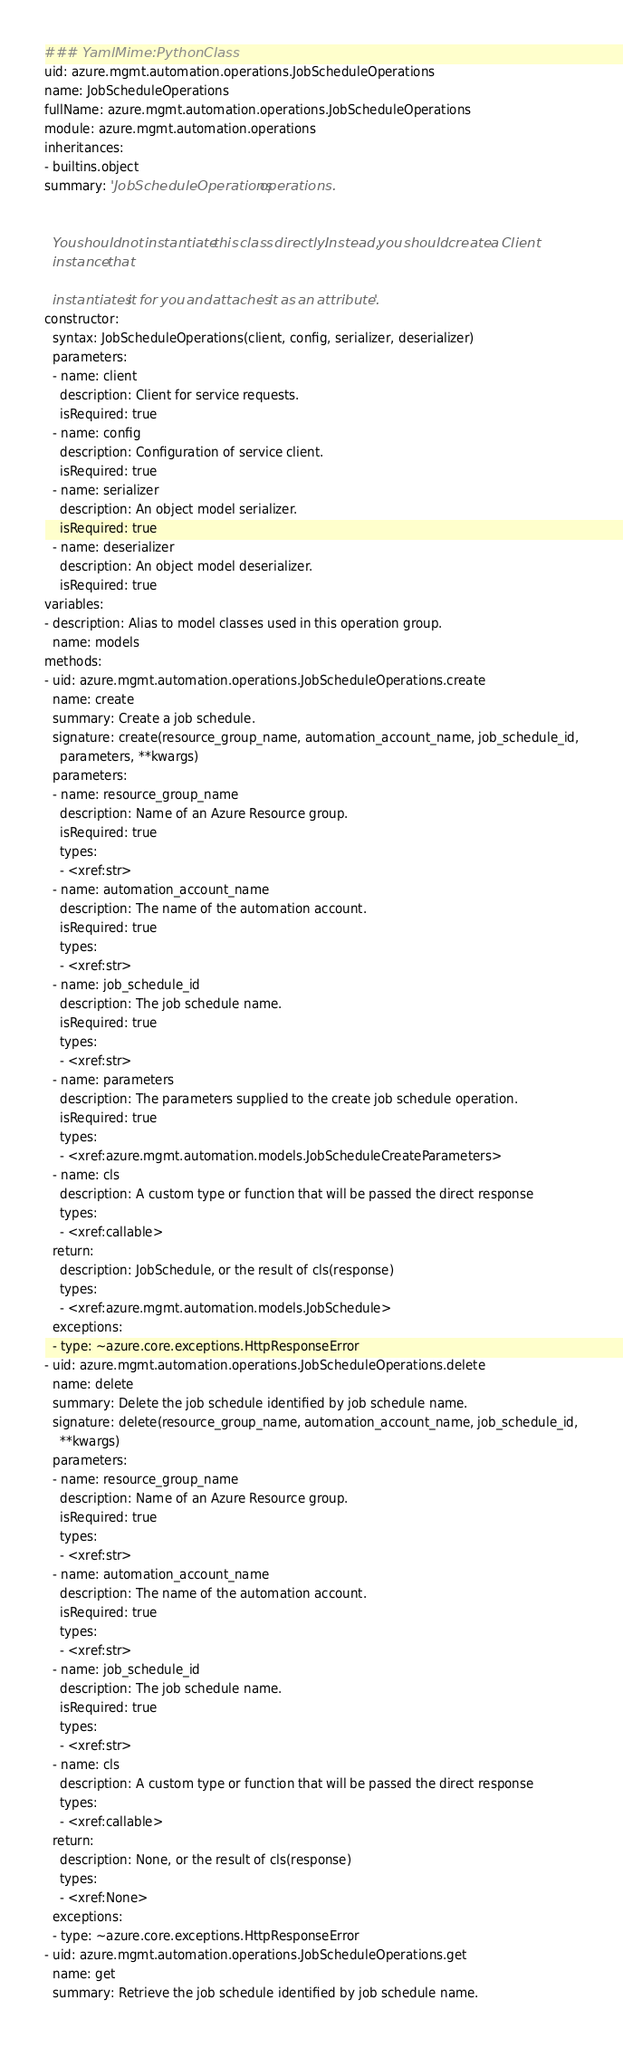Convert code to text. <code><loc_0><loc_0><loc_500><loc_500><_YAML_>### YamlMime:PythonClass
uid: azure.mgmt.automation.operations.JobScheduleOperations
name: JobScheduleOperations
fullName: azure.mgmt.automation.operations.JobScheduleOperations
module: azure.mgmt.automation.operations
inheritances:
- builtins.object
summary: 'JobScheduleOperations operations.


  You should not instantiate this class directly. Instead, you should create a Client
  instance that

  instantiates it for you and attaches it as an attribute.'
constructor:
  syntax: JobScheduleOperations(client, config, serializer, deserializer)
  parameters:
  - name: client
    description: Client for service requests.
    isRequired: true
  - name: config
    description: Configuration of service client.
    isRequired: true
  - name: serializer
    description: An object model serializer.
    isRequired: true
  - name: deserializer
    description: An object model deserializer.
    isRequired: true
variables:
- description: Alias to model classes used in this operation group.
  name: models
methods:
- uid: azure.mgmt.automation.operations.JobScheduleOperations.create
  name: create
  summary: Create a job schedule.
  signature: create(resource_group_name, automation_account_name, job_schedule_id,
    parameters, **kwargs)
  parameters:
  - name: resource_group_name
    description: Name of an Azure Resource group.
    isRequired: true
    types:
    - <xref:str>
  - name: automation_account_name
    description: The name of the automation account.
    isRequired: true
    types:
    - <xref:str>
  - name: job_schedule_id
    description: The job schedule name.
    isRequired: true
    types:
    - <xref:str>
  - name: parameters
    description: The parameters supplied to the create job schedule operation.
    isRequired: true
    types:
    - <xref:azure.mgmt.automation.models.JobScheduleCreateParameters>
  - name: cls
    description: A custom type or function that will be passed the direct response
    types:
    - <xref:callable>
  return:
    description: JobSchedule, or the result of cls(response)
    types:
    - <xref:azure.mgmt.automation.models.JobSchedule>
  exceptions:
  - type: ~azure.core.exceptions.HttpResponseError
- uid: azure.mgmt.automation.operations.JobScheduleOperations.delete
  name: delete
  summary: Delete the job schedule identified by job schedule name.
  signature: delete(resource_group_name, automation_account_name, job_schedule_id,
    **kwargs)
  parameters:
  - name: resource_group_name
    description: Name of an Azure Resource group.
    isRequired: true
    types:
    - <xref:str>
  - name: automation_account_name
    description: The name of the automation account.
    isRequired: true
    types:
    - <xref:str>
  - name: job_schedule_id
    description: The job schedule name.
    isRequired: true
    types:
    - <xref:str>
  - name: cls
    description: A custom type or function that will be passed the direct response
    types:
    - <xref:callable>
  return:
    description: None, or the result of cls(response)
    types:
    - <xref:None>
  exceptions:
  - type: ~azure.core.exceptions.HttpResponseError
- uid: azure.mgmt.automation.operations.JobScheduleOperations.get
  name: get
  summary: Retrieve the job schedule identified by job schedule name.</code> 